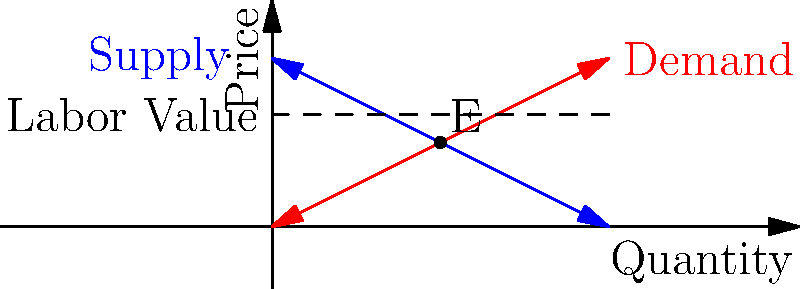In the context of Marxist economic theory, analyze the graph depicting supply and demand curves alongside a horizontal line representing labor value. How does this model challenge or support the labor theory of value, and what implications does it have for the relationship between commodity prices and labor value in a capitalist market system? To answer this question, we need to consider several key points:

1. Labor Theory of Value: Marx posited that the value of a commodity is determined by the socially necessary labor time required for its production.

2. Supply and Demand: The graph shows traditional supply (blue) and demand (red) curves intersecting at point E, which represents the market equilibrium price and quantity.

3. Labor Value Line: The horizontal dashed line represents the labor value of the commodity, which is constant regardless of supply and demand fluctuations.

4. Price-Value Divergence: The equilibrium price (at point E) differs from the labor value, illustrating a potential contradiction between market prices and labor value.

5. Market Forces: The graph suggests that supply and demand forces can cause prices to deviate from labor value, challenging a simplistic interpretation of the labor theory of value.

6. Social Relations: From a Marxist perspective, this divergence reflects the social relations of production in a capitalist system, where market mechanisms can obscure the true value of labor.

7. Surplus Value: The difference between the market price and labor value could be interpreted as surplus value extracted by capitalists, a key concept in Marxist economics.

8. Dynamic Analysis: A Marxist critique would emphasize that this static model doesn't capture the full complexity of economic relations and historical materialism.

9. Commodity Fetishism: The graph might be seen as an example of commodity fetishism, where social relations are obscured by market relations.

10. Dialectical Approach: A Marxist analysis would stress the need to understand the contradictions inherent in this model and how they relate to broader economic and social structures.
Answer: The graph illustrates the contradiction between market-determined prices and labor value, supporting Marx's critique of capitalist markets while challenging simplistic interpretations of the labor theory of value. It demonstrates how social relations in capitalism can lead to a divergence between price and value, potentially obscuring exploitation and surplus value extraction. 